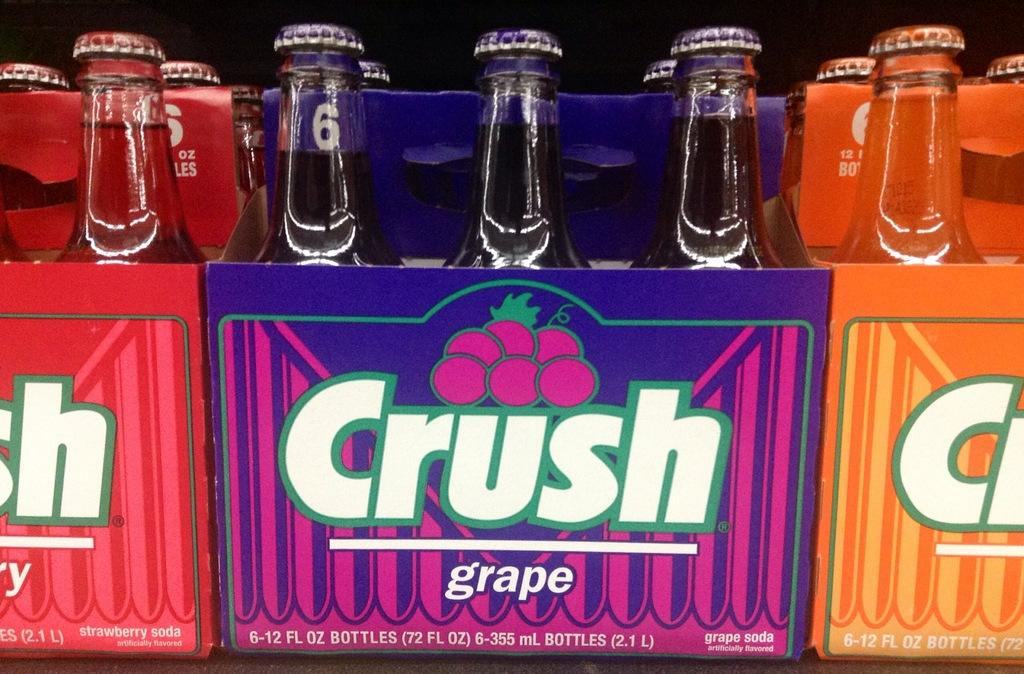<image>
Describe the image concisely. A six pack of bottles by Crush in the grape flavor. 